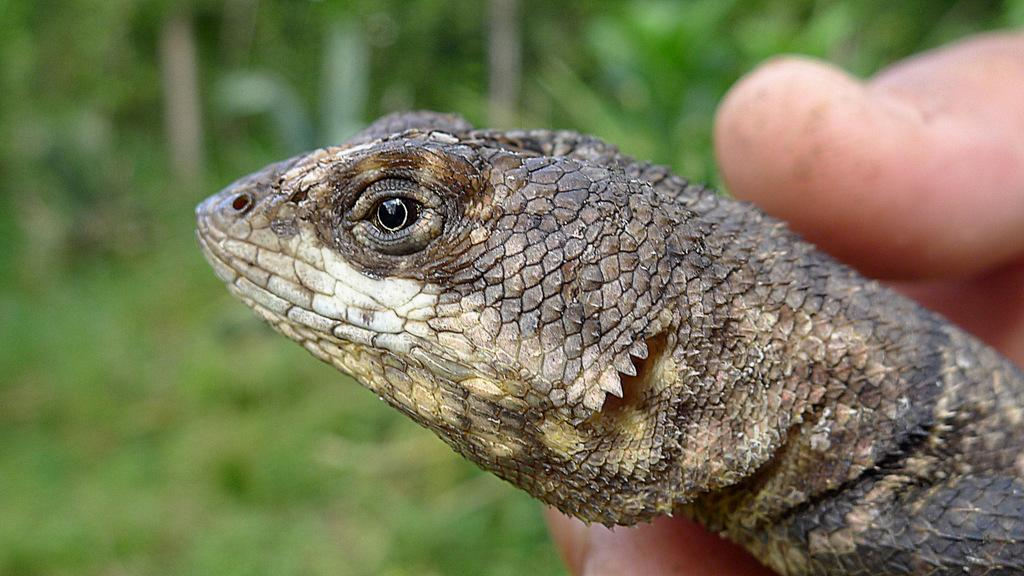What can be seen in the image? There is a person's hand in the image. What is the hand holding? The hand is holding a reptile. Can you describe the background of the image? The background of the image is blurred. What mathematical operation is being performed by the hand in the image? There is no mathematical operation being performed by the hand in the image; it is holding a reptile. 